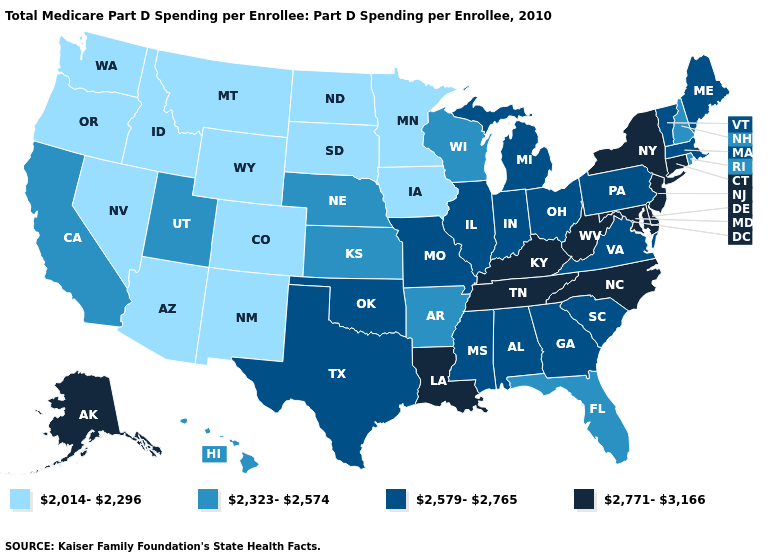Name the states that have a value in the range 2,323-2,574?
Concise answer only. Arkansas, California, Florida, Hawaii, Kansas, Nebraska, New Hampshire, Rhode Island, Utah, Wisconsin. Name the states that have a value in the range 2,771-3,166?
Be succinct. Alaska, Connecticut, Delaware, Kentucky, Louisiana, Maryland, New Jersey, New York, North Carolina, Tennessee, West Virginia. What is the value of Illinois?
Short answer required. 2,579-2,765. What is the value of Pennsylvania?
Give a very brief answer. 2,579-2,765. What is the value of West Virginia?
Answer briefly. 2,771-3,166. What is the value of Nebraska?
Keep it brief. 2,323-2,574. Name the states that have a value in the range 2,771-3,166?
Concise answer only. Alaska, Connecticut, Delaware, Kentucky, Louisiana, Maryland, New Jersey, New York, North Carolina, Tennessee, West Virginia. Does New York have a higher value than North Carolina?
Be succinct. No. What is the value of New Hampshire?
Be succinct. 2,323-2,574. Name the states that have a value in the range 2,323-2,574?
Quick response, please. Arkansas, California, Florida, Hawaii, Kansas, Nebraska, New Hampshire, Rhode Island, Utah, Wisconsin. Does the first symbol in the legend represent the smallest category?
Quick response, please. Yes. Name the states that have a value in the range 2,323-2,574?
Short answer required. Arkansas, California, Florida, Hawaii, Kansas, Nebraska, New Hampshire, Rhode Island, Utah, Wisconsin. What is the value of Virginia?
Answer briefly. 2,579-2,765. What is the value of Ohio?
Concise answer only. 2,579-2,765. Among the states that border New Mexico , does Colorado have the highest value?
Concise answer only. No. 